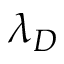Convert formula to latex. <formula><loc_0><loc_0><loc_500><loc_500>\lambda _ { D }</formula> 